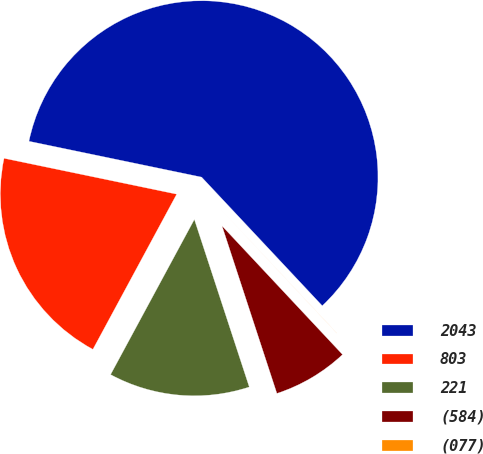<chart> <loc_0><loc_0><loc_500><loc_500><pie_chart><fcel>2043<fcel>803<fcel>221<fcel>(584)<fcel>(077)<nl><fcel>59.75%<fcel>20.38%<fcel>12.92%<fcel>6.94%<fcel>0.01%<nl></chart> 